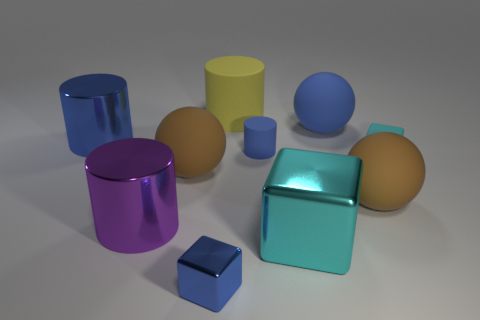Subtract all big blocks. How many blocks are left? 2 Subtract all purple blocks. How many brown spheres are left? 2 Subtract all purple cylinders. How many cylinders are left? 3 Subtract 2 cylinders. How many cylinders are left? 2 Subtract all spheres. How many objects are left? 7 Subtract all gray blocks. Subtract all purple spheres. How many blocks are left? 3 Subtract all large cyan things. Subtract all large blue rubber objects. How many objects are left? 8 Add 2 big cyan metal cubes. How many big cyan metal cubes are left? 3 Add 8 purple matte blocks. How many purple matte blocks exist? 8 Subtract 2 brown spheres. How many objects are left? 8 